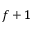Convert formula to latex. <formula><loc_0><loc_0><loc_500><loc_500>f + 1</formula> 